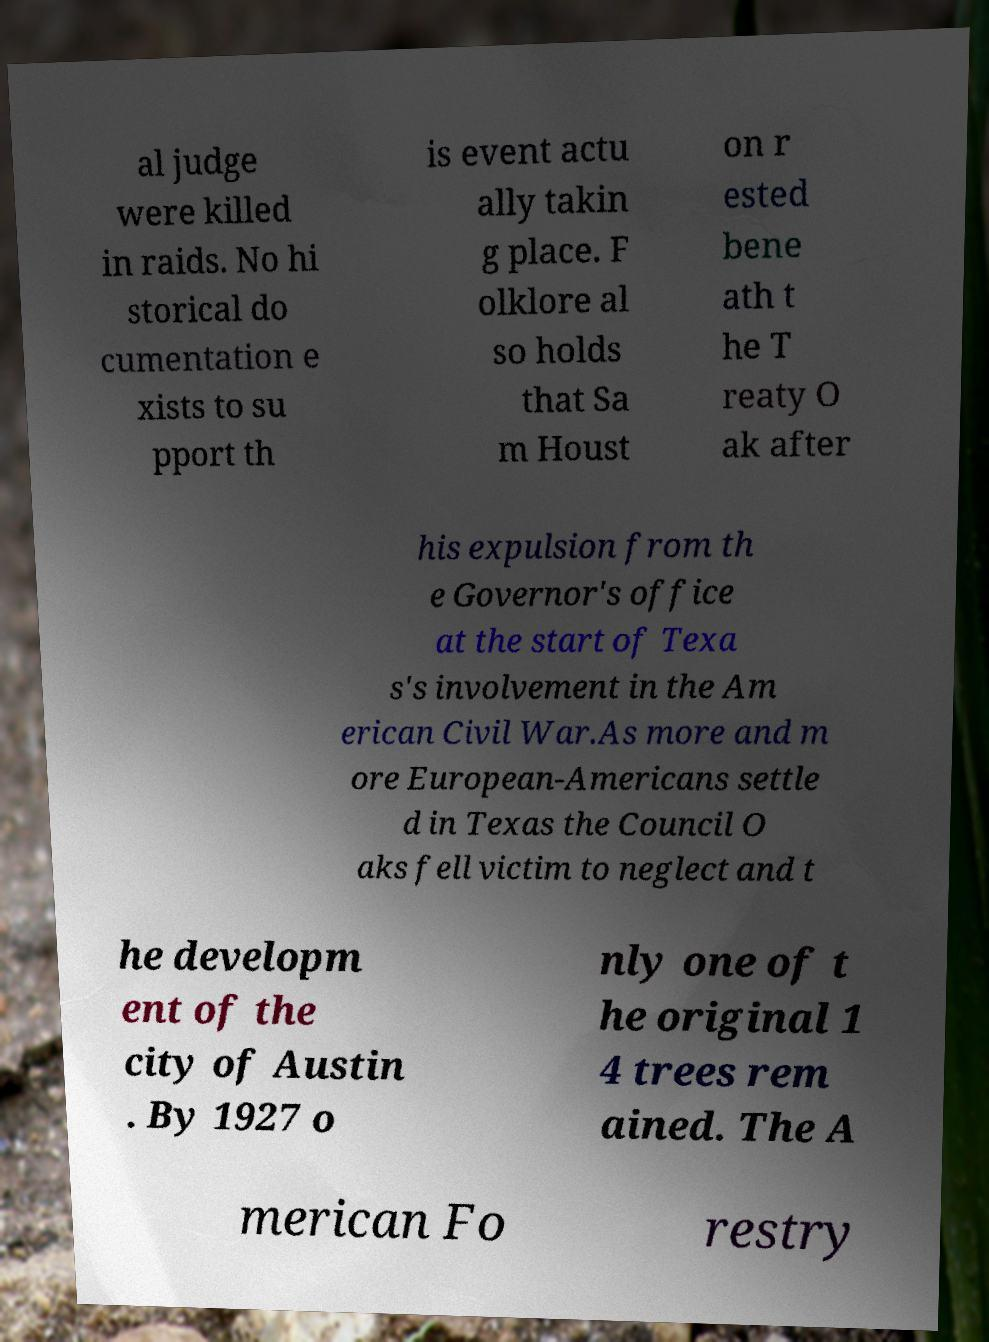What messages or text are displayed in this image? I need them in a readable, typed format. al judge were killed in raids. No hi storical do cumentation e xists to su pport th is event actu ally takin g place. F olklore al so holds that Sa m Houst on r ested bene ath t he T reaty O ak after his expulsion from th e Governor's office at the start of Texa s's involvement in the Am erican Civil War.As more and m ore European-Americans settle d in Texas the Council O aks fell victim to neglect and t he developm ent of the city of Austin . By 1927 o nly one of t he original 1 4 trees rem ained. The A merican Fo restry 